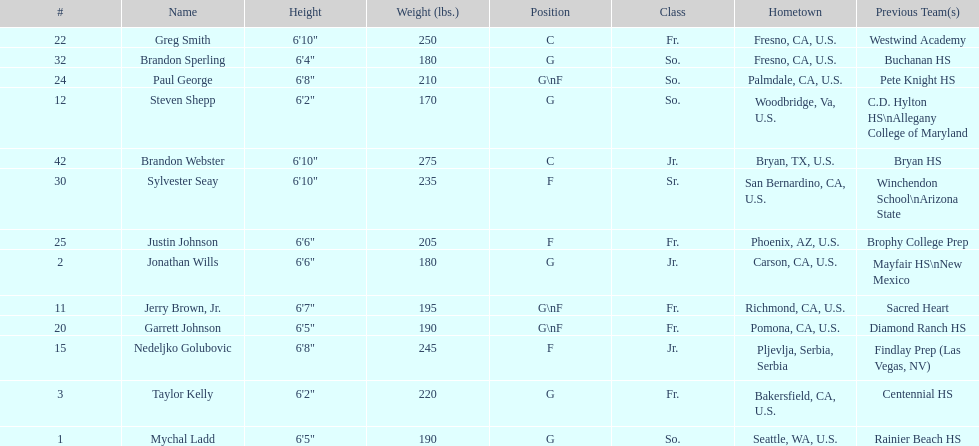Among forwards (f) only, which player has the least height? Justin Johnson. 